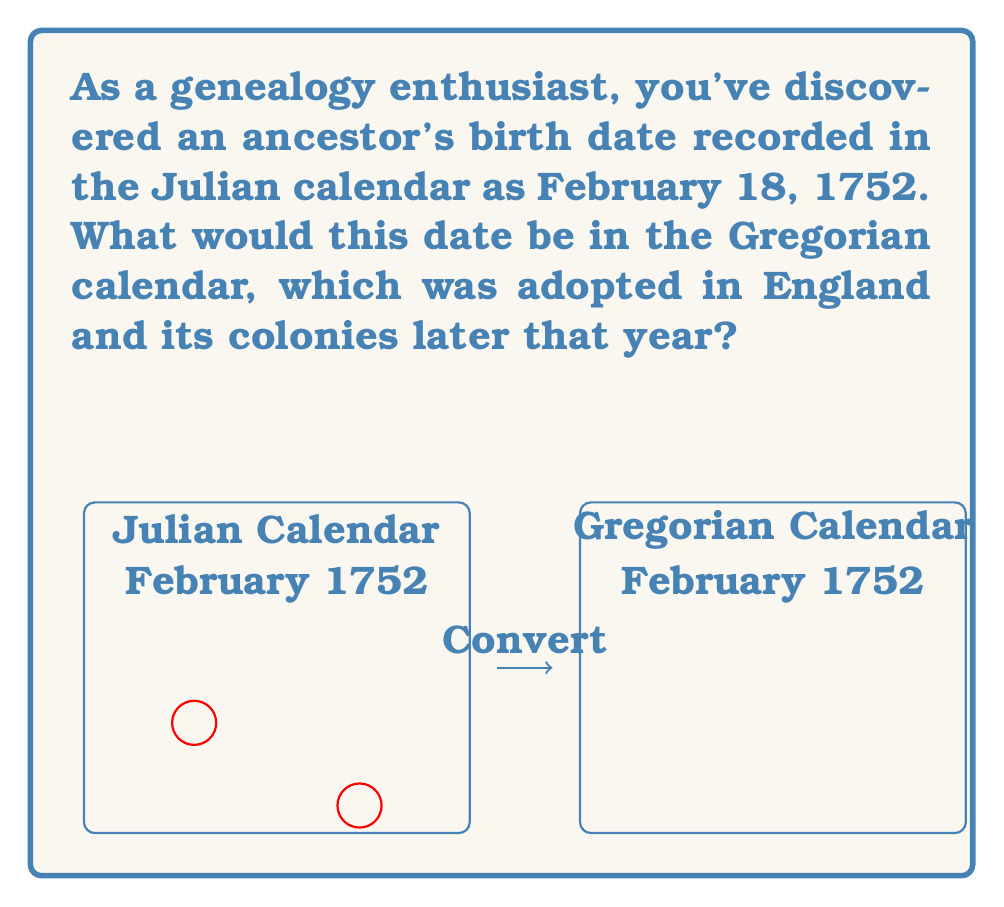Show me your answer to this math problem. To convert a date from the Julian calendar to the Gregorian calendar during this period, we need to follow these steps:

1) Understand the difference between calendars:
   The Julian calendar was 11 days behind the Gregorian calendar in the 18th century.

2) Add 11 days to the Julian date:
   February 18 + 11 days = February 29

3) Consider the year:
   In 1752, England and its colonies switched from the Julian to the Gregorian calendar in September. Before this switch, the new year in the Julian calendar started on March 25.

4) Adjust the year if necessary:
   Since our date is in February, it's before March 25. In the Julian calendar, this would still be considered 1751. However, in the Gregorian calendar, the year would be 1752.

5) Final result:
   The date February 18, 1752 (Julian) converts to February 29, 1752 (Gregorian).

Note: This conversion is particularly interesting for genealogists because it falls in the year when England adopted the Gregorian calendar, leading to a complex year with a mix of calendar systems.

The equation for this conversion can be expressed as:

$$D_G = D_J + 11$$

Where $D_G$ is the Gregorian date and $D_J$ is the Julian date.
Answer: February 29, 1752 